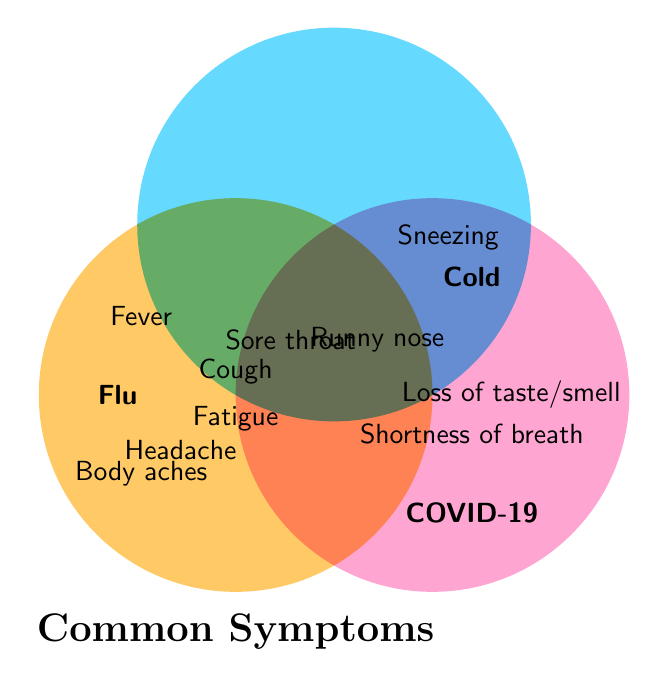What symptoms are common to all three illnesses? The overlapping area of the Venn diagram for Flu, Cold, and COVID-19 shows symptoms that are common to all three. From the figure, Cough, Fatigue, Sore throat, and Headache are located in the overlapping section.
Answer: Cough, Fatigue, Sore throat, Headache Which illness has "Loss of taste/smell" as a symptom? "Loss of taste/smell" appears in the section exclusive to COVID-19. It isn't found in the areas representing Flu or Cold.
Answer: COVID-19 What symptoms do Flu and COVID-19 share that the Cold does not? The intersection between Flu and COVID-19 but not Cold includes the area where these two overlap without including the Cold section. From the figure, these symptoms are Fever and Body aches.
Answer: Fever, Body aches Which symptom is unique to the Flu? By looking at the area exclusively for Flu and not shared with other diseases, we can identify that this section does not list any specific symptoms.
Answer: None Are there any symptoms shared only by Cold and COVID-19 but not by the Flu? The shared area between Cold and COVID-19 and excluding Flu appears as the intersection between these two circles only. The symptom "Runny nose" is placed in this overlapping section.
Answer: Runny nose What symptoms are only related to Cold? The area exclusively for the Cold in the Venn diagram lists symptoms attributed to Cold alone. From the figure, the symptom "Sneezing" appears here.
Answer: Sneezing Which symptom is shared by Cold and Flu but not related to COVID-19? The overlapping area of Cold and Flu, but excluding COVID-19, would only show the symptoms specific to these two illnesses. The figure does not show such an area meaning no such symptoms exist.
Answer: None What does the diagram title state? The title of the diagram, positioned centrally, summarizes the overall content and subject matter, as written in clear text.
Answer: Common Symptoms 